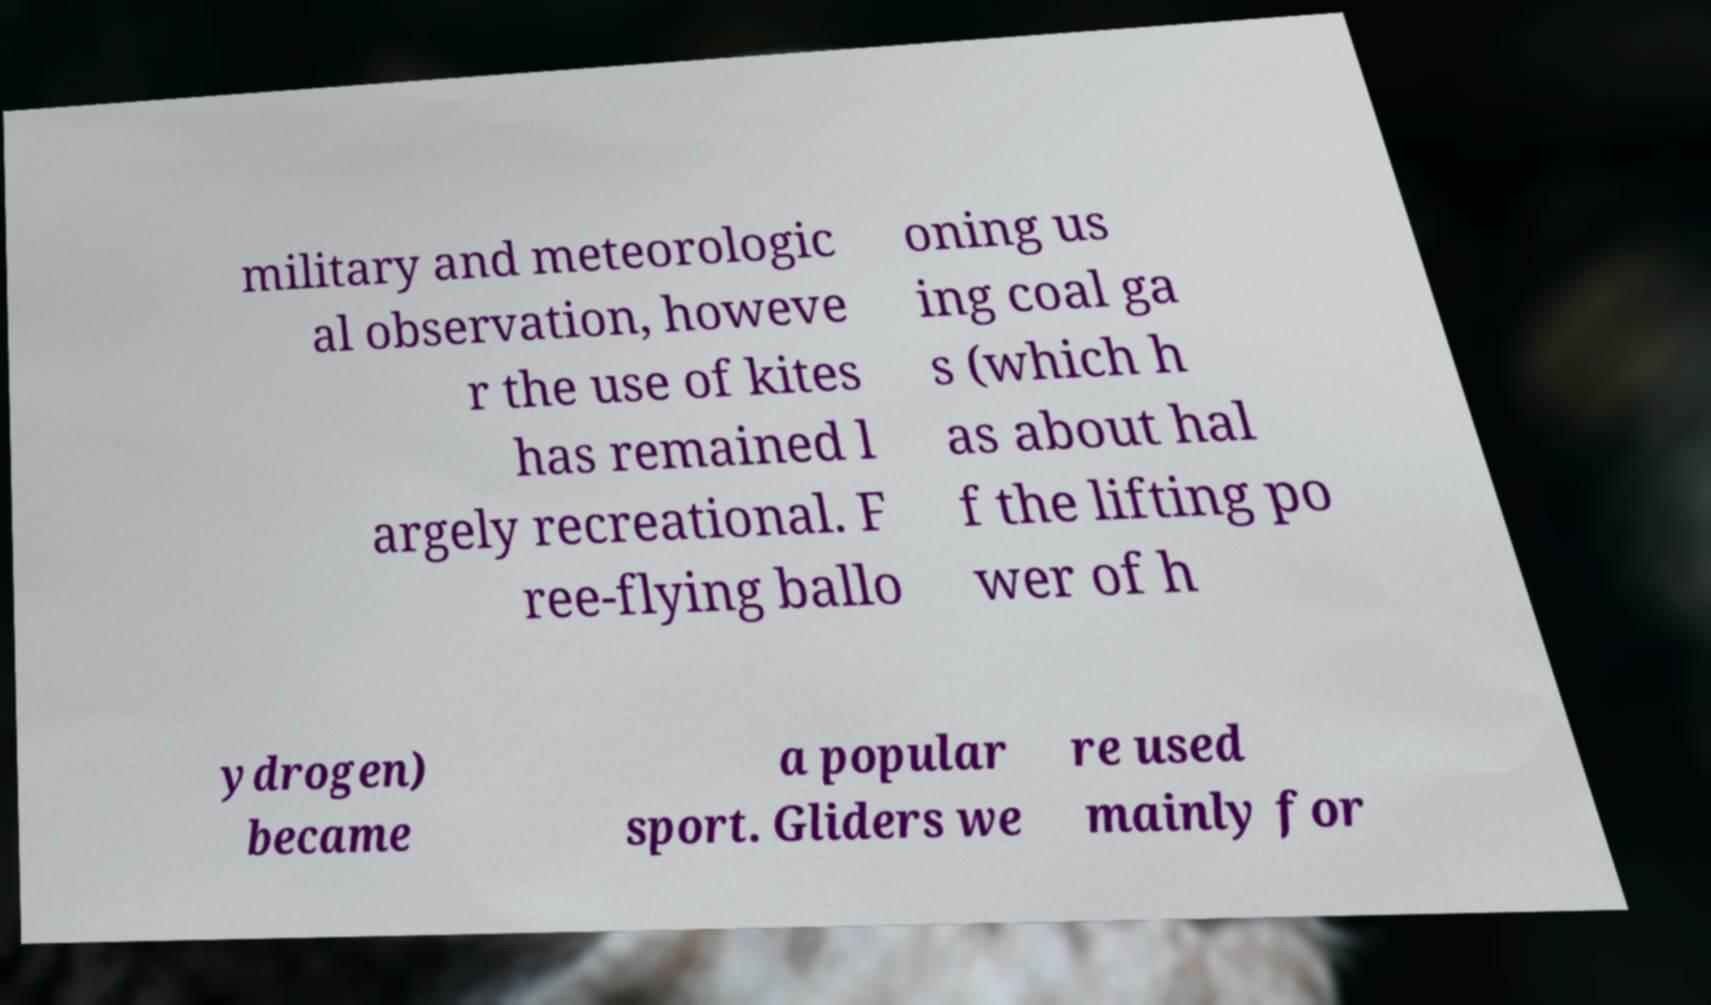I need the written content from this picture converted into text. Can you do that? military and meteorologic al observation, howeve r the use of kites has remained l argely recreational. F ree-flying ballo oning us ing coal ga s (which h as about hal f the lifting po wer of h ydrogen) became a popular sport. Gliders we re used mainly for 